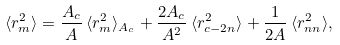Convert formula to latex. <formula><loc_0><loc_0><loc_500><loc_500>\langle r _ { m } ^ { 2 } \rangle = \frac { A _ { c } } { A } \, \langle r _ { m } ^ { 2 } \rangle _ { A _ { c } } + \frac { 2 A _ { c } } { A ^ { 2 } } \, \langle r _ { c - 2 n } ^ { 2 } \rangle + \frac { 1 } { 2 A } \, \langle r _ { n n } ^ { 2 } \rangle ,</formula> 